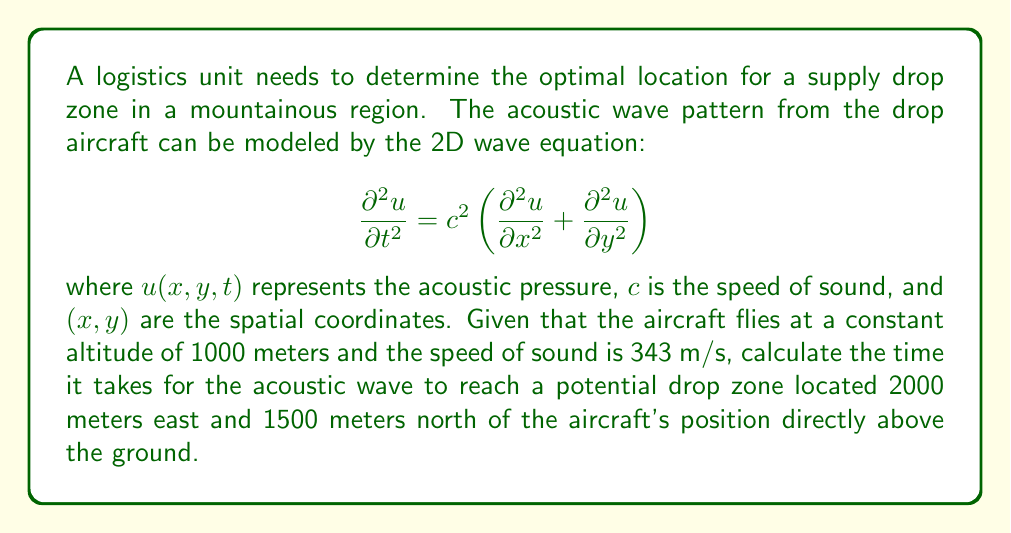Solve this math problem. To solve this problem, we'll follow these steps:

1) First, we need to determine the total distance the acoustic wave travels from the aircraft to the potential drop zone. We can use the Pythagorean theorem in 3D space.

2) Let's define our coordinates:
   - Aircraft position: (0, 0, 1000)
   - Drop zone position: (2000, 1500, 0)

3) The distance $d$ is given by:

   $$d = \sqrt{(x_2-x_1)^2 + (y_2-y_1)^2 + (z_2-z_1)^2}$$

   $$d = \sqrt{(2000-0)^2 + (1500-0)^2 + (0-1000)^2}$$

   $$d = \sqrt{4,000,000 + 2,250,000 + 1,000,000}$$

   $$d = \sqrt{7,250,000} = 2692.582 \text{ meters}$$

4) Now that we have the distance, we can calculate the time using the formula:

   $$t = \frac{d}{c}$$

   where $t$ is time, $d$ is distance, and $c$ is the speed of sound.

5) Plugging in our values:

   $$t = \frac{2692.582 \text{ m}}{343 \text{ m/s}} = 7.8501 \text{ seconds}$$

Therefore, it takes approximately 7.8501 seconds for the acoustic wave to reach the potential drop zone.
Answer: 7.8501 seconds 